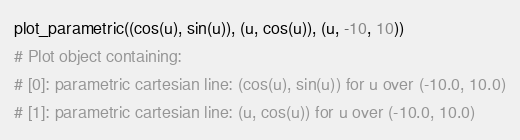Convert code to text. <code><loc_0><loc_0><loc_500><loc_500><_Python_>plot_parametric((cos(u), sin(u)), (u, cos(u)), (u, -10, 10))
# Plot object containing:
# [0]: parametric cartesian line: (cos(u), sin(u)) for u over (-10.0, 10.0)
# [1]: parametric cartesian line: (u, cos(u)) for u over (-10.0, 10.0)
</code> 